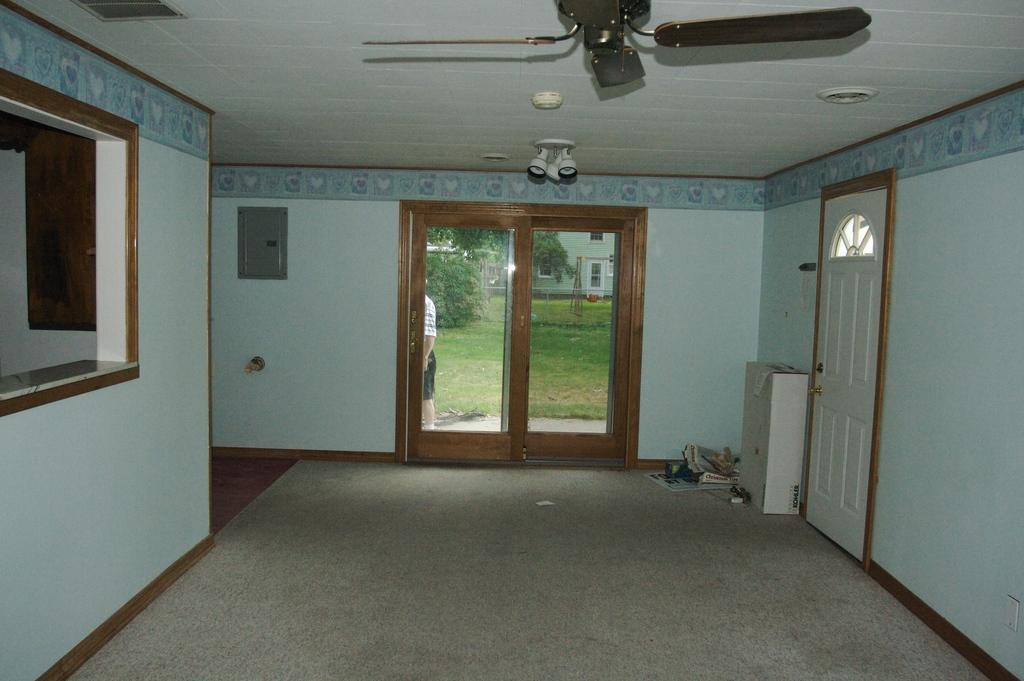Describe this image in one or two sentences. In this image we can see a wooden door, wall and also some objects on the floor. We can also see the glass door and through the glass door we can see a person, grass, building and also trees. At the top we can see a fan, lights and also the ceiling. 